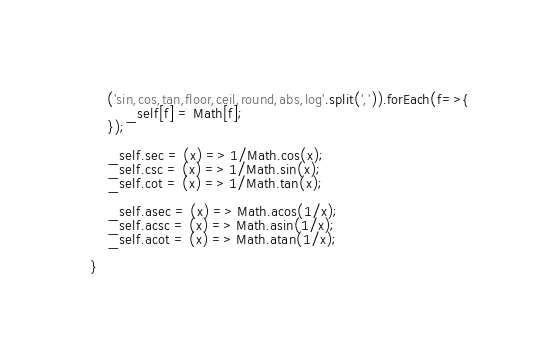Convert code to text. <code><loc_0><loc_0><loc_500><loc_500><_JavaScript_>
    ('sin,cos,tan,floor,ceil,round,abs,log'.split(',')).forEach(f=>{
        _self[f] = Math[f];
    });

    _self.sec = (x) => 1/Math.cos(x);
    _self.csc = (x) => 1/Math.sin(x);
    _self.cot = (x) => 1/Math.tan(x);

    _self.asec = (x) => Math.acos(1/x);
    _self.acsc = (x) => Math.asin(1/x);
    _self.acot = (x) => Math.atan(1/x);

}</code> 